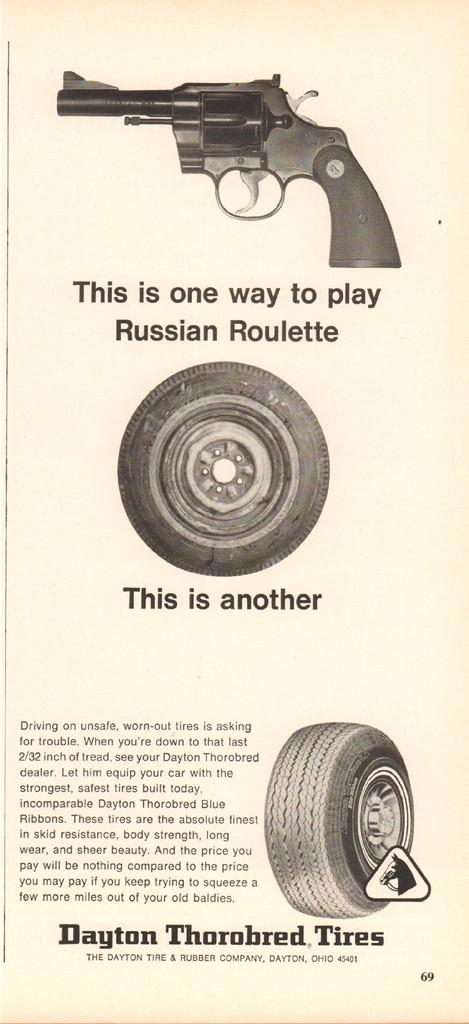What is featured on the poster in the image? The poster consists of a pistol. What type of riddle can be seen written on the poster with chalk? There is no riddle or chalk present on the poster in the image; it only features a pistol. 